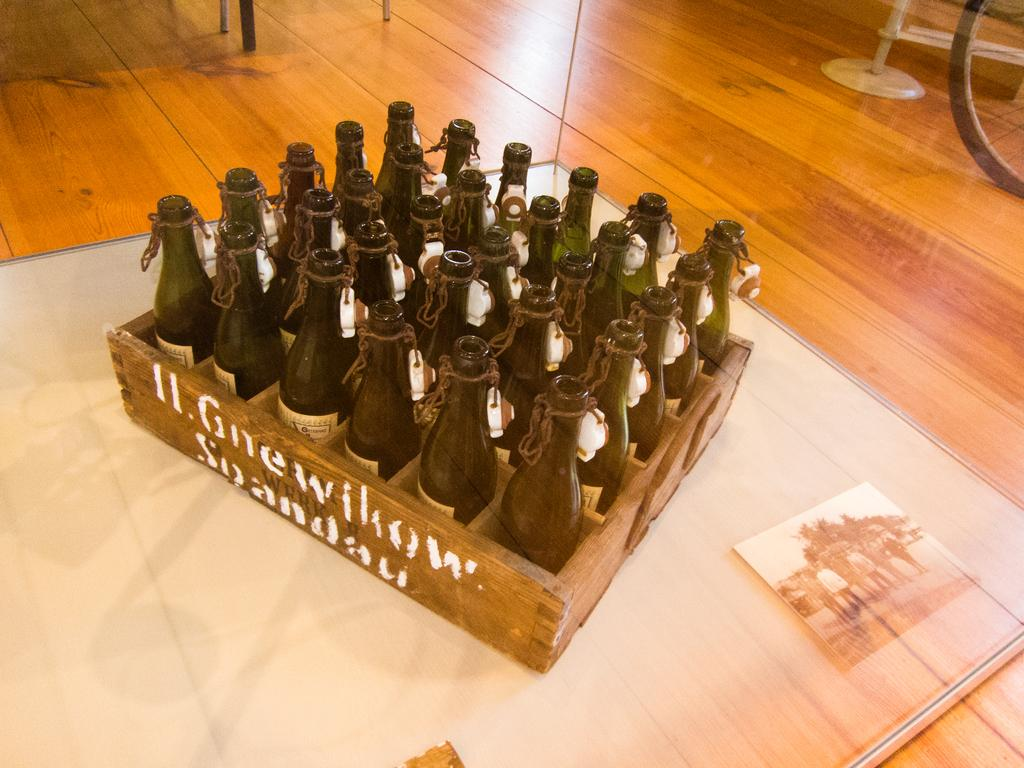<image>
Render a clear and concise summary of the photo. 30 empty bottles of beer inside a box labeled Il. Gnewilon Soandau 